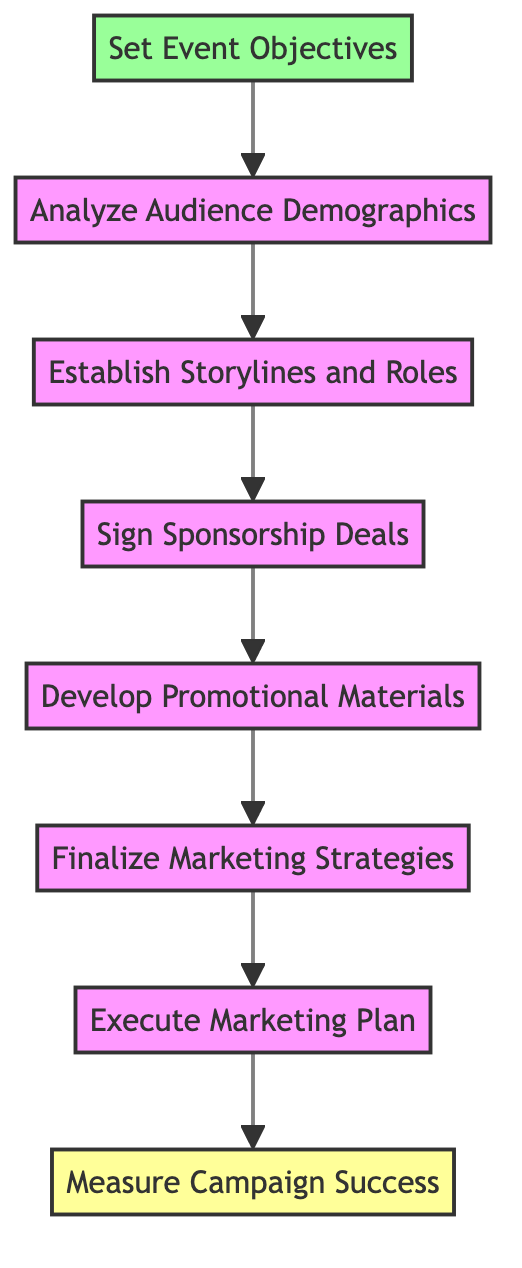What is the first step in the campaign process? The first step indicated in the diagram is "Set Event Objectives," which is at the bottom. This is the starting point before any other actions are taken.
Answer: Set Event Objectives How many nodes are there in total? By counting the individual steps represented in the flowchart, there are a total of eight nodes, each representing a specific part of the campaign process.
Answer: 8 What is the last step in the campaign process? The last step, as shown in the diagram, is "Measure Campaign Success," which is at the top of the flow. This reflects the final evaluation phase after the campaign execution.
Answer: Measure Campaign Success Which step comes after establishing storylines and roles? According to the flow of the diagram, "Sign Sponsorship Deals" follows immediately after "Establish Storylines and Roles," indicating that sponsorships are arranged based on the planned storylines.
Answer: Sign Sponsorship Deals What step involves creating promotional materials? The diagram shows that "Develop Promotional Materials" is the step dedicated to the creation of these materials and comes after signing sponsorship deals.
Answer: Develop Promotional Materials What are the main strategies finalized before executing the plan? The step "Finalize Marketing Strategies" is specifically where the strategies are defined before moving to implementation, indicating that this is a preparatory phase.
Answer: Finalize Marketing Strategies How does "Analyze Audience Demographics" relate to "Set Event Objectives"? "Analyze Audience Demographics" directly follows "Set Event Objectives," indicating that understanding the audience is crucial for shaping the event's goals.
Answer: Analyze Audience Demographics What is the relationship between sponsorship deals and promotional materials? According to the flowchart, "Sign Sponsorship Deals" leads directly to "Develop Promotional Materials," suggesting that sponsorship funding likely influences the creation of these materials.
Answer: Sign Sponsorship Deals leads to Develop Promotional Materials What is the total flow of the diagram from start to finish? The flowchart outlines a process that begins with "Set Event Objectives" and ends with "Measure Campaign Success," emphasizing that each step builds on the previous one.
Answer: Set Event Objectives to Measure Campaign Success 